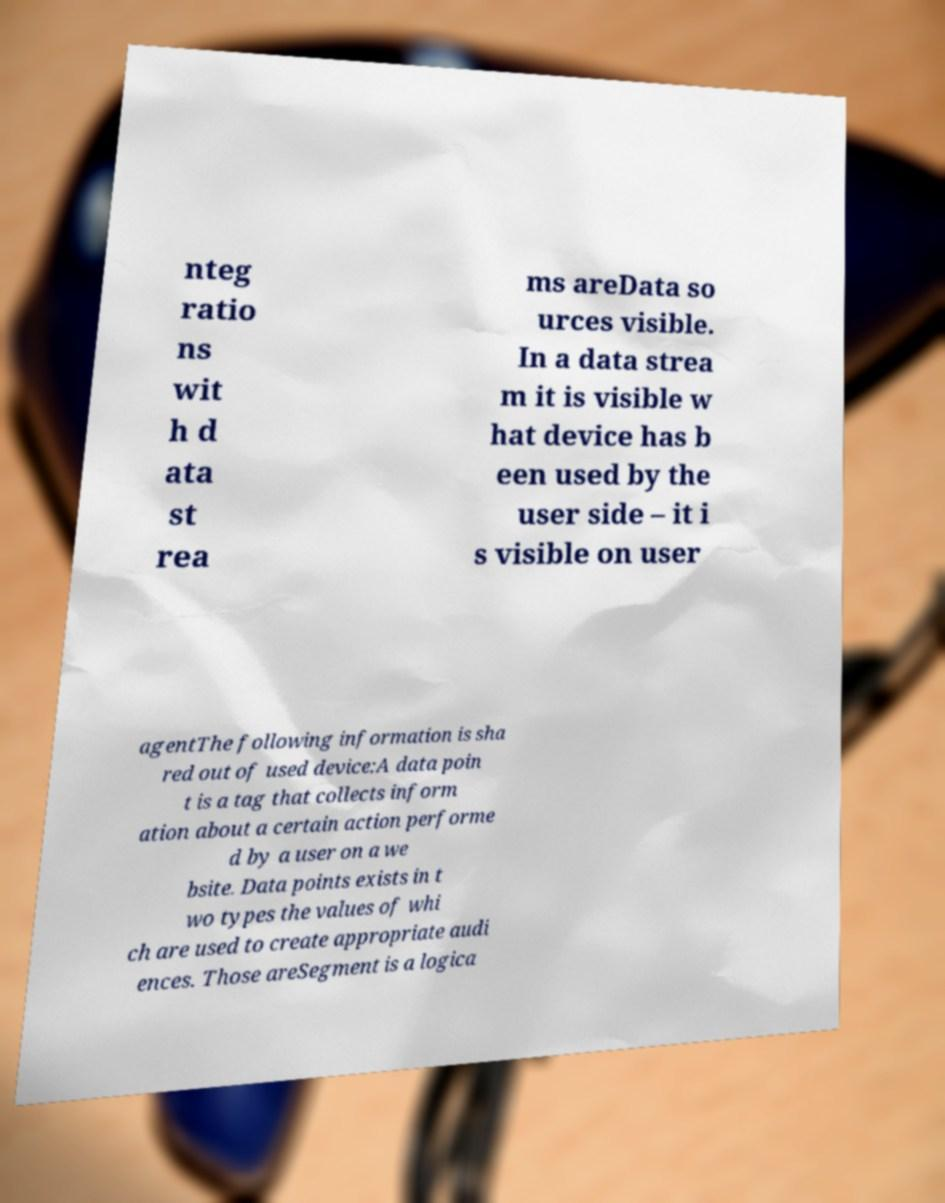Could you assist in decoding the text presented in this image and type it out clearly? nteg ratio ns wit h d ata st rea ms areData so urces visible. In a data strea m it is visible w hat device has b een used by the user side – it i s visible on user agentThe following information is sha red out of used device:A data poin t is a tag that collects inform ation about a certain action performe d by a user on a we bsite. Data points exists in t wo types the values of whi ch are used to create appropriate audi ences. Those areSegment is a logica 